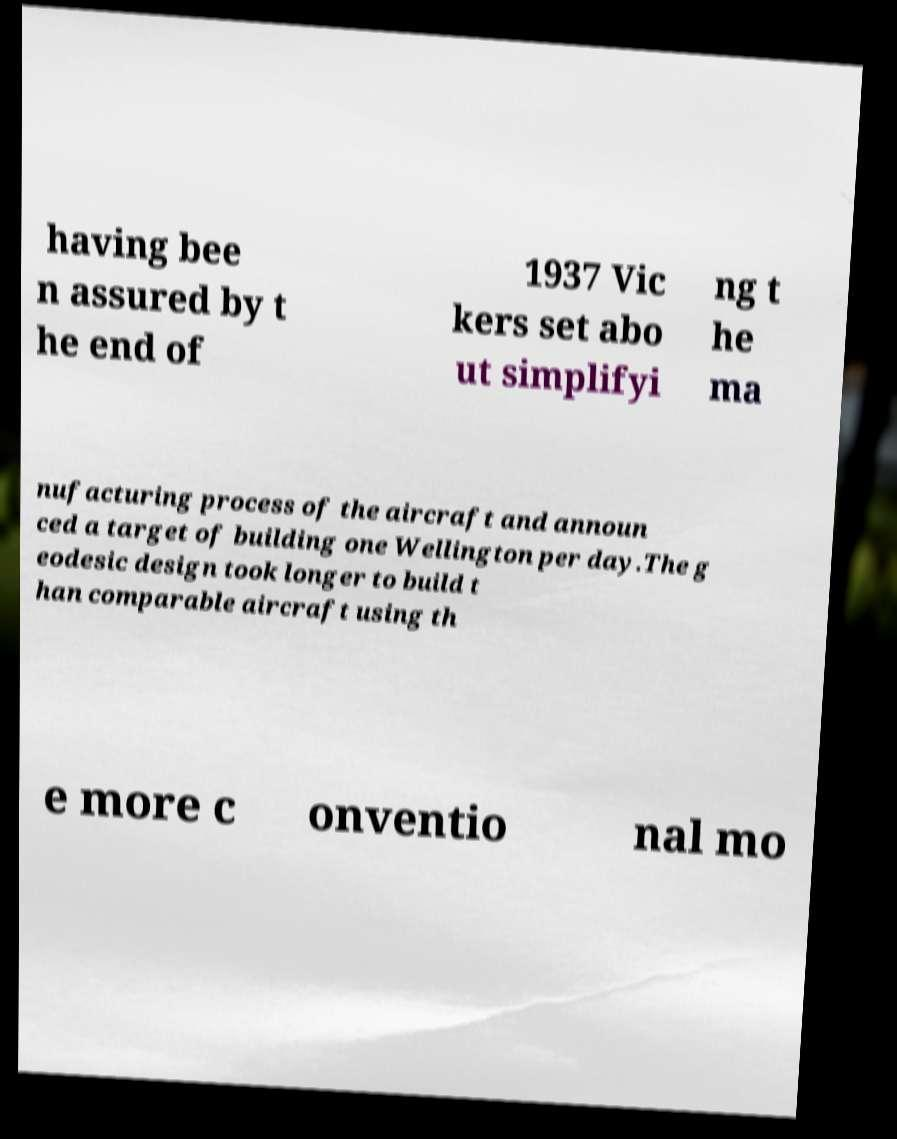Can you read and provide the text displayed in the image?This photo seems to have some interesting text. Can you extract and type it out for me? having bee n assured by t he end of 1937 Vic kers set abo ut simplifyi ng t he ma nufacturing process of the aircraft and announ ced a target of building one Wellington per day.The g eodesic design took longer to build t han comparable aircraft using th e more c onventio nal mo 